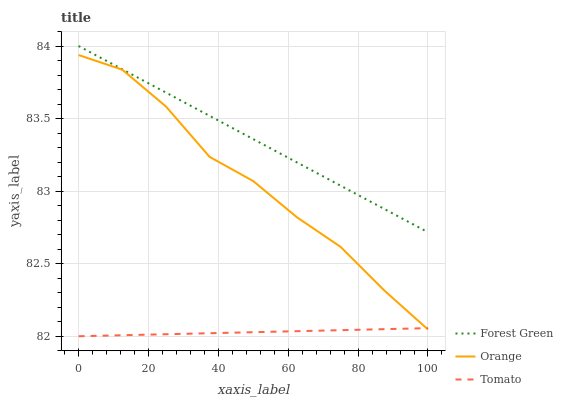Does Forest Green have the minimum area under the curve?
Answer yes or no. No. Does Tomato have the maximum area under the curve?
Answer yes or no. No. Is Tomato the smoothest?
Answer yes or no. No. Is Tomato the roughest?
Answer yes or no. No. Does Forest Green have the lowest value?
Answer yes or no. No. Does Tomato have the highest value?
Answer yes or no. No. Is Orange less than Forest Green?
Answer yes or no. Yes. Is Forest Green greater than Tomato?
Answer yes or no. Yes. Does Orange intersect Forest Green?
Answer yes or no. No. 